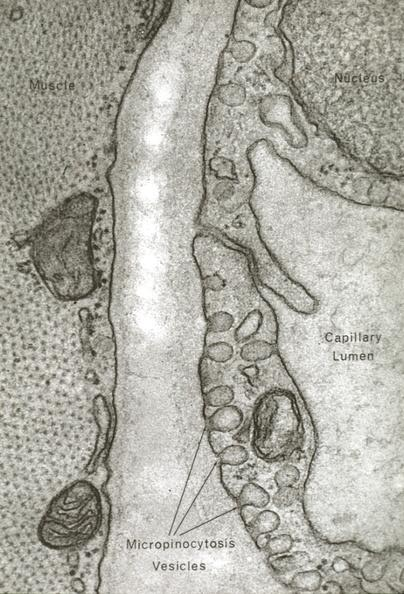s vasculature present?
Answer the question using a single word or phrase. Yes 